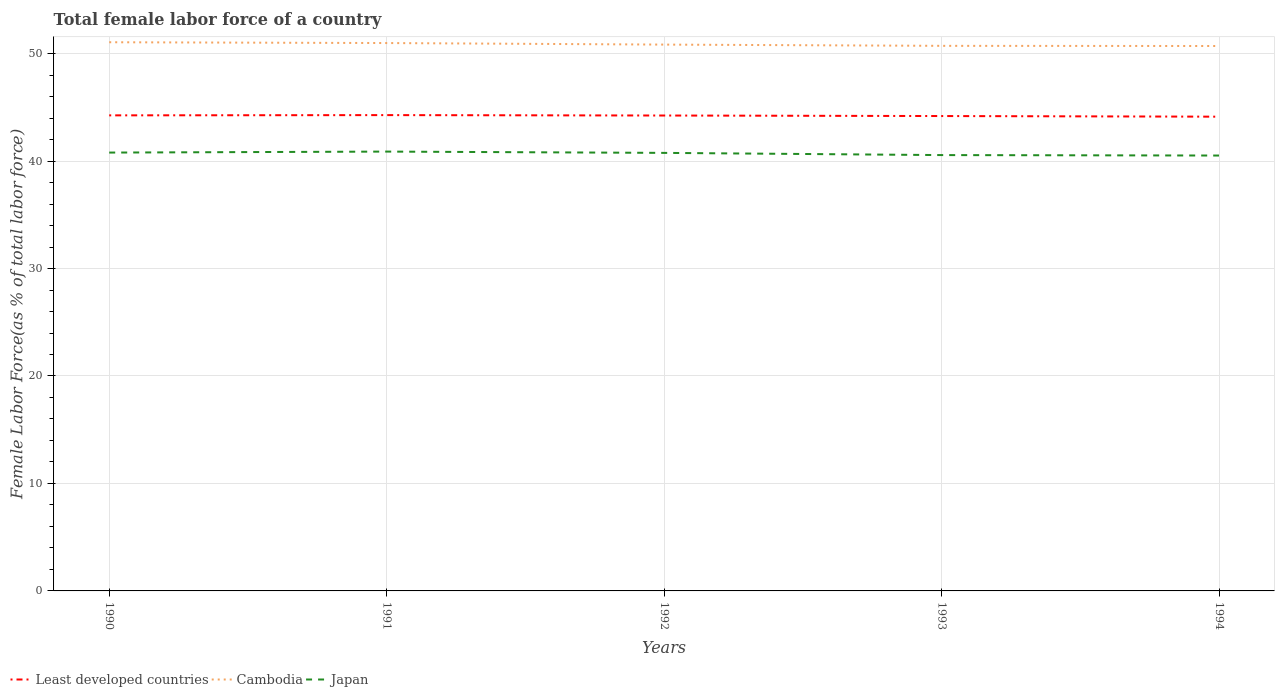How many different coloured lines are there?
Give a very brief answer. 3. Is the number of lines equal to the number of legend labels?
Keep it short and to the point. Yes. Across all years, what is the maximum percentage of female labor force in Japan?
Provide a short and direct response. 40.52. In which year was the percentage of female labor force in Least developed countries maximum?
Give a very brief answer. 1994. What is the total percentage of female labor force in Japan in the graph?
Offer a very short reply. 0.37. What is the difference between the highest and the second highest percentage of female labor force in Least developed countries?
Ensure brevity in your answer.  0.15. How many years are there in the graph?
Ensure brevity in your answer.  5. Are the values on the major ticks of Y-axis written in scientific E-notation?
Ensure brevity in your answer.  No. Does the graph contain grids?
Offer a very short reply. Yes. Where does the legend appear in the graph?
Make the answer very short. Bottom left. How are the legend labels stacked?
Make the answer very short. Horizontal. What is the title of the graph?
Your response must be concise. Total female labor force of a country. Does "Algeria" appear as one of the legend labels in the graph?
Your response must be concise. No. What is the label or title of the X-axis?
Your answer should be compact. Years. What is the label or title of the Y-axis?
Provide a succinct answer. Female Labor Force(as % of total labor force). What is the Female Labor Force(as % of total labor force) in Least developed countries in 1990?
Provide a succinct answer. 44.25. What is the Female Labor Force(as % of total labor force) in Cambodia in 1990?
Offer a very short reply. 51.06. What is the Female Labor Force(as % of total labor force) in Japan in 1990?
Provide a succinct answer. 40.79. What is the Female Labor Force(as % of total labor force) in Least developed countries in 1991?
Provide a succinct answer. 44.28. What is the Female Labor Force(as % of total labor force) of Cambodia in 1991?
Provide a succinct answer. 50.98. What is the Female Labor Force(as % of total labor force) of Japan in 1991?
Provide a succinct answer. 40.88. What is the Female Labor Force(as % of total labor force) of Least developed countries in 1992?
Provide a short and direct response. 44.24. What is the Female Labor Force(as % of total labor force) of Cambodia in 1992?
Ensure brevity in your answer.  50.84. What is the Female Labor Force(as % of total labor force) of Japan in 1992?
Provide a succinct answer. 40.76. What is the Female Labor Force(as % of total labor force) of Least developed countries in 1993?
Keep it short and to the point. 44.19. What is the Female Labor Force(as % of total labor force) in Cambodia in 1993?
Offer a very short reply. 50.72. What is the Female Labor Force(as % of total labor force) of Japan in 1993?
Offer a very short reply. 40.56. What is the Female Labor Force(as % of total labor force) in Least developed countries in 1994?
Keep it short and to the point. 44.13. What is the Female Labor Force(as % of total labor force) in Cambodia in 1994?
Make the answer very short. 50.71. What is the Female Labor Force(as % of total labor force) in Japan in 1994?
Keep it short and to the point. 40.52. Across all years, what is the maximum Female Labor Force(as % of total labor force) in Least developed countries?
Your response must be concise. 44.28. Across all years, what is the maximum Female Labor Force(as % of total labor force) in Cambodia?
Offer a very short reply. 51.06. Across all years, what is the maximum Female Labor Force(as % of total labor force) of Japan?
Your answer should be compact. 40.88. Across all years, what is the minimum Female Labor Force(as % of total labor force) in Least developed countries?
Keep it short and to the point. 44.13. Across all years, what is the minimum Female Labor Force(as % of total labor force) of Cambodia?
Offer a terse response. 50.71. Across all years, what is the minimum Female Labor Force(as % of total labor force) in Japan?
Provide a succinct answer. 40.52. What is the total Female Labor Force(as % of total labor force) in Least developed countries in the graph?
Make the answer very short. 221.09. What is the total Female Labor Force(as % of total labor force) of Cambodia in the graph?
Your response must be concise. 254.31. What is the total Female Labor Force(as % of total labor force) in Japan in the graph?
Ensure brevity in your answer.  203.51. What is the difference between the Female Labor Force(as % of total labor force) in Least developed countries in 1990 and that in 1991?
Ensure brevity in your answer.  -0.02. What is the difference between the Female Labor Force(as % of total labor force) of Cambodia in 1990 and that in 1991?
Your response must be concise. 0.07. What is the difference between the Female Labor Force(as % of total labor force) of Japan in 1990 and that in 1991?
Provide a succinct answer. -0.09. What is the difference between the Female Labor Force(as % of total labor force) of Least developed countries in 1990 and that in 1992?
Keep it short and to the point. 0.01. What is the difference between the Female Labor Force(as % of total labor force) of Cambodia in 1990 and that in 1992?
Keep it short and to the point. 0.22. What is the difference between the Female Labor Force(as % of total labor force) of Japan in 1990 and that in 1992?
Your answer should be very brief. 0.03. What is the difference between the Female Labor Force(as % of total labor force) of Least developed countries in 1990 and that in 1993?
Ensure brevity in your answer.  0.06. What is the difference between the Female Labor Force(as % of total labor force) in Cambodia in 1990 and that in 1993?
Keep it short and to the point. 0.34. What is the difference between the Female Labor Force(as % of total labor force) of Japan in 1990 and that in 1993?
Your answer should be very brief. 0.23. What is the difference between the Female Labor Force(as % of total labor force) in Least developed countries in 1990 and that in 1994?
Keep it short and to the point. 0.12. What is the difference between the Female Labor Force(as % of total labor force) in Cambodia in 1990 and that in 1994?
Keep it short and to the point. 0.35. What is the difference between the Female Labor Force(as % of total labor force) of Japan in 1990 and that in 1994?
Provide a short and direct response. 0.28. What is the difference between the Female Labor Force(as % of total labor force) of Least developed countries in 1991 and that in 1992?
Offer a terse response. 0.04. What is the difference between the Female Labor Force(as % of total labor force) of Cambodia in 1991 and that in 1992?
Provide a succinct answer. 0.14. What is the difference between the Female Labor Force(as % of total labor force) in Japan in 1991 and that in 1992?
Make the answer very short. 0.12. What is the difference between the Female Labor Force(as % of total labor force) in Least developed countries in 1991 and that in 1993?
Your response must be concise. 0.09. What is the difference between the Female Labor Force(as % of total labor force) of Cambodia in 1991 and that in 1993?
Offer a terse response. 0.26. What is the difference between the Female Labor Force(as % of total labor force) of Japan in 1991 and that in 1993?
Your answer should be compact. 0.33. What is the difference between the Female Labor Force(as % of total labor force) of Least developed countries in 1991 and that in 1994?
Provide a succinct answer. 0.15. What is the difference between the Female Labor Force(as % of total labor force) of Cambodia in 1991 and that in 1994?
Your response must be concise. 0.28. What is the difference between the Female Labor Force(as % of total labor force) of Japan in 1991 and that in 1994?
Your answer should be compact. 0.37. What is the difference between the Female Labor Force(as % of total labor force) of Least developed countries in 1992 and that in 1993?
Provide a short and direct response. 0.05. What is the difference between the Female Labor Force(as % of total labor force) in Cambodia in 1992 and that in 1993?
Make the answer very short. 0.12. What is the difference between the Female Labor Force(as % of total labor force) of Japan in 1992 and that in 1993?
Offer a terse response. 0.2. What is the difference between the Female Labor Force(as % of total labor force) in Least developed countries in 1992 and that in 1994?
Provide a short and direct response. 0.11. What is the difference between the Female Labor Force(as % of total labor force) of Cambodia in 1992 and that in 1994?
Make the answer very short. 0.13. What is the difference between the Female Labor Force(as % of total labor force) of Japan in 1992 and that in 1994?
Give a very brief answer. 0.25. What is the difference between the Female Labor Force(as % of total labor force) in Least developed countries in 1993 and that in 1994?
Provide a short and direct response. 0.06. What is the difference between the Female Labor Force(as % of total labor force) of Cambodia in 1993 and that in 1994?
Keep it short and to the point. 0.02. What is the difference between the Female Labor Force(as % of total labor force) of Japan in 1993 and that in 1994?
Offer a terse response. 0.04. What is the difference between the Female Labor Force(as % of total labor force) of Least developed countries in 1990 and the Female Labor Force(as % of total labor force) of Cambodia in 1991?
Keep it short and to the point. -6.73. What is the difference between the Female Labor Force(as % of total labor force) in Least developed countries in 1990 and the Female Labor Force(as % of total labor force) in Japan in 1991?
Make the answer very short. 3.37. What is the difference between the Female Labor Force(as % of total labor force) of Cambodia in 1990 and the Female Labor Force(as % of total labor force) of Japan in 1991?
Offer a very short reply. 10.18. What is the difference between the Female Labor Force(as % of total labor force) of Least developed countries in 1990 and the Female Labor Force(as % of total labor force) of Cambodia in 1992?
Your response must be concise. -6.58. What is the difference between the Female Labor Force(as % of total labor force) in Least developed countries in 1990 and the Female Labor Force(as % of total labor force) in Japan in 1992?
Provide a succinct answer. 3.49. What is the difference between the Female Labor Force(as % of total labor force) in Cambodia in 1990 and the Female Labor Force(as % of total labor force) in Japan in 1992?
Make the answer very short. 10.3. What is the difference between the Female Labor Force(as % of total labor force) in Least developed countries in 1990 and the Female Labor Force(as % of total labor force) in Cambodia in 1993?
Keep it short and to the point. -6.47. What is the difference between the Female Labor Force(as % of total labor force) in Least developed countries in 1990 and the Female Labor Force(as % of total labor force) in Japan in 1993?
Offer a very short reply. 3.7. What is the difference between the Female Labor Force(as % of total labor force) in Cambodia in 1990 and the Female Labor Force(as % of total labor force) in Japan in 1993?
Your response must be concise. 10.5. What is the difference between the Female Labor Force(as % of total labor force) of Least developed countries in 1990 and the Female Labor Force(as % of total labor force) of Cambodia in 1994?
Provide a succinct answer. -6.45. What is the difference between the Female Labor Force(as % of total labor force) of Least developed countries in 1990 and the Female Labor Force(as % of total labor force) of Japan in 1994?
Offer a terse response. 3.74. What is the difference between the Female Labor Force(as % of total labor force) of Cambodia in 1990 and the Female Labor Force(as % of total labor force) of Japan in 1994?
Give a very brief answer. 10.54. What is the difference between the Female Labor Force(as % of total labor force) of Least developed countries in 1991 and the Female Labor Force(as % of total labor force) of Cambodia in 1992?
Give a very brief answer. -6.56. What is the difference between the Female Labor Force(as % of total labor force) in Least developed countries in 1991 and the Female Labor Force(as % of total labor force) in Japan in 1992?
Make the answer very short. 3.52. What is the difference between the Female Labor Force(as % of total labor force) in Cambodia in 1991 and the Female Labor Force(as % of total labor force) in Japan in 1992?
Make the answer very short. 10.22. What is the difference between the Female Labor Force(as % of total labor force) of Least developed countries in 1991 and the Female Labor Force(as % of total labor force) of Cambodia in 1993?
Give a very brief answer. -6.45. What is the difference between the Female Labor Force(as % of total labor force) in Least developed countries in 1991 and the Female Labor Force(as % of total labor force) in Japan in 1993?
Your answer should be very brief. 3.72. What is the difference between the Female Labor Force(as % of total labor force) in Cambodia in 1991 and the Female Labor Force(as % of total labor force) in Japan in 1993?
Your response must be concise. 10.43. What is the difference between the Female Labor Force(as % of total labor force) in Least developed countries in 1991 and the Female Labor Force(as % of total labor force) in Cambodia in 1994?
Offer a very short reply. -6.43. What is the difference between the Female Labor Force(as % of total labor force) of Least developed countries in 1991 and the Female Labor Force(as % of total labor force) of Japan in 1994?
Give a very brief answer. 3.76. What is the difference between the Female Labor Force(as % of total labor force) in Cambodia in 1991 and the Female Labor Force(as % of total labor force) in Japan in 1994?
Provide a short and direct response. 10.47. What is the difference between the Female Labor Force(as % of total labor force) of Least developed countries in 1992 and the Female Labor Force(as % of total labor force) of Cambodia in 1993?
Offer a very short reply. -6.48. What is the difference between the Female Labor Force(as % of total labor force) in Least developed countries in 1992 and the Female Labor Force(as % of total labor force) in Japan in 1993?
Keep it short and to the point. 3.68. What is the difference between the Female Labor Force(as % of total labor force) in Cambodia in 1992 and the Female Labor Force(as % of total labor force) in Japan in 1993?
Make the answer very short. 10.28. What is the difference between the Female Labor Force(as % of total labor force) of Least developed countries in 1992 and the Female Labor Force(as % of total labor force) of Cambodia in 1994?
Provide a short and direct response. -6.47. What is the difference between the Female Labor Force(as % of total labor force) in Least developed countries in 1992 and the Female Labor Force(as % of total labor force) in Japan in 1994?
Your response must be concise. 3.72. What is the difference between the Female Labor Force(as % of total labor force) in Cambodia in 1992 and the Female Labor Force(as % of total labor force) in Japan in 1994?
Ensure brevity in your answer.  10.32. What is the difference between the Female Labor Force(as % of total labor force) in Least developed countries in 1993 and the Female Labor Force(as % of total labor force) in Cambodia in 1994?
Offer a terse response. -6.52. What is the difference between the Female Labor Force(as % of total labor force) in Least developed countries in 1993 and the Female Labor Force(as % of total labor force) in Japan in 1994?
Provide a short and direct response. 3.68. What is the difference between the Female Labor Force(as % of total labor force) of Cambodia in 1993 and the Female Labor Force(as % of total labor force) of Japan in 1994?
Offer a very short reply. 10.21. What is the average Female Labor Force(as % of total labor force) in Least developed countries per year?
Ensure brevity in your answer.  44.22. What is the average Female Labor Force(as % of total labor force) of Cambodia per year?
Provide a succinct answer. 50.86. What is the average Female Labor Force(as % of total labor force) in Japan per year?
Your response must be concise. 40.7. In the year 1990, what is the difference between the Female Labor Force(as % of total labor force) in Least developed countries and Female Labor Force(as % of total labor force) in Cambodia?
Your response must be concise. -6.8. In the year 1990, what is the difference between the Female Labor Force(as % of total labor force) of Least developed countries and Female Labor Force(as % of total labor force) of Japan?
Your response must be concise. 3.46. In the year 1990, what is the difference between the Female Labor Force(as % of total labor force) in Cambodia and Female Labor Force(as % of total labor force) in Japan?
Offer a very short reply. 10.27. In the year 1991, what is the difference between the Female Labor Force(as % of total labor force) in Least developed countries and Female Labor Force(as % of total labor force) in Cambodia?
Give a very brief answer. -6.71. In the year 1991, what is the difference between the Female Labor Force(as % of total labor force) of Least developed countries and Female Labor Force(as % of total labor force) of Japan?
Your response must be concise. 3.39. In the year 1991, what is the difference between the Female Labor Force(as % of total labor force) of Cambodia and Female Labor Force(as % of total labor force) of Japan?
Keep it short and to the point. 10.1. In the year 1992, what is the difference between the Female Labor Force(as % of total labor force) in Least developed countries and Female Labor Force(as % of total labor force) in Cambodia?
Your answer should be compact. -6.6. In the year 1992, what is the difference between the Female Labor Force(as % of total labor force) of Least developed countries and Female Labor Force(as % of total labor force) of Japan?
Ensure brevity in your answer.  3.48. In the year 1992, what is the difference between the Female Labor Force(as % of total labor force) in Cambodia and Female Labor Force(as % of total labor force) in Japan?
Keep it short and to the point. 10.08. In the year 1993, what is the difference between the Female Labor Force(as % of total labor force) of Least developed countries and Female Labor Force(as % of total labor force) of Cambodia?
Your answer should be compact. -6.53. In the year 1993, what is the difference between the Female Labor Force(as % of total labor force) in Least developed countries and Female Labor Force(as % of total labor force) in Japan?
Offer a very short reply. 3.63. In the year 1993, what is the difference between the Female Labor Force(as % of total labor force) of Cambodia and Female Labor Force(as % of total labor force) of Japan?
Give a very brief answer. 10.17. In the year 1994, what is the difference between the Female Labor Force(as % of total labor force) in Least developed countries and Female Labor Force(as % of total labor force) in Cambodia?
Provide a succinct answer. -6.58. In the year 1994, what is the difference between the Female Labor Force(as % of total labor force) of Least developed countries and Female Labor Force(as % of total labor force) of Japan?
Make the answer very short. 3.62. In the year 1994, what is the difference between the Female Labor Force(as % of total labor force) of Cambodia and Female Labor Force(as % of total labor force) of Japan?
Provide a short and direct response. 10.19. What is the ratio of the Female Labor Force(as % of total labor force) of Cambodia in 1990 to that in 1993?
Offer a very short reply. 1.01. What is the ratio of the Female Labor Force(as % of total labor force) of Japan in 1990 to that in 1993?
Offer a very short reply. 1.01. What is the ratio of the Female Labor Force(as % of total labor force) in Cambodia in 1990 to that in 1994?
Provide a short and direct response. 1.01. What is the ratio of the Female Labor Force(as % of total labor force) of Japan in 1990 to that in 1994?
Ensure brevity in your answer.  1.01. What is the ratio of the Female Labor Force(as % of total labor force) in Least developed countries in 1991 to that in 1992?
Give a very brief answer. 1. What is the ratio of the Female Labor Force(as % of total labor force) in Japan in 1991 to that in 1992?
Offer a very short reply. 1. What is the ratio of the Female Labor Force(as % of total labor force) in Cambodia in 1991 to that in 1993?
Keep it short and to the point. 1.01. What is the ratio of the Female Labor Force(as % of total labor force) in Cambodia in 1991 to that in 1994?
Make the answer very short. 1.01. What is the ratio of the Female Labor Force(as % of total labor force) of Japan in 1991 to that in 1994?
Keep it short and to the point. 1.01. What is the ratio of the Female Labor Force(as % of total labor force) of Least developed countries in 1992 to that in 1993?
Your response must be concise. 1. What is the ratio of the Female Labor Force(as % of total labor force) in Japan in 1992 to that in 1993?
Offer a very short reply. 1. What is the ratio of the Female Labor Force(as % of total labor force) in Least developed countries in 1992 to that in 1994?
Offer a very short reply. 1. What is the ratio of the Female Labor Force(as % of total labor force) in Japan in 1993 to that in 1994?
Provide a succinct answer. 1. What is the difference between the highest and the second highest Female Labor Force(as % of total labor force) of Least developed countries?
Give a very brief answer. 0.02. What is the difference between the highest and the second highest Female Labor Force(as % of total labor force) of Cambodia?
Make the answer very short. 0.07. What is the difference between the highest and the second highest Female Labor Force(as % of total labor force) in Japan?
Your response must be concise. 0.09. What is the difference between the highest and the lowest Female Labor Force(as % of total labor force) of Least developed countries?
Your answer should be compact. 0.15. What is the difference between the highest and the lowest Female Labor Force(as % of total labor force) of Cambodia?
Your answer should be compact. 0.35. What is the difference between the highest and the lowest Female Labor Force(as % of total labor force) in Japan?
Provide a short and direct response. 0.37. 